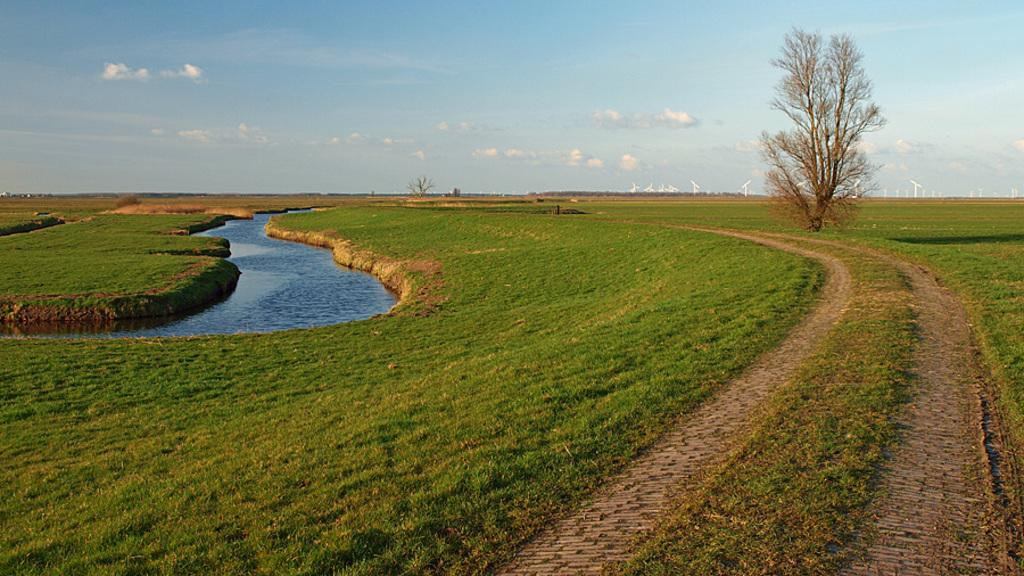What type of surface can be seen in the image? There is a road in the image. What type of vegetation is present on the ground in the image? There is grass on the ground in the image. What natural element is visible in the image? There is water visible in the image. How many trees are present in the image? There is one tree in the image, and another tree in the background. What can be seen in the background of the image? There are white-colored poles, another tree, and the sky visible in the background of the image. What type of drink is being served on the shelf in the image? There is no shelf or drink present in the image. How much salt is visible on the ground in the image? There is no salt visible on the ground in the image. 